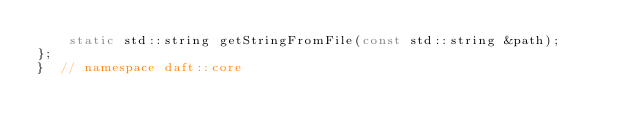<code> <loc_0><loc_0><loc_500><loc_500><_C++_>    static std::string getStringFromFile(const std::string &path);
};
}  // namespace daft::core</code> 